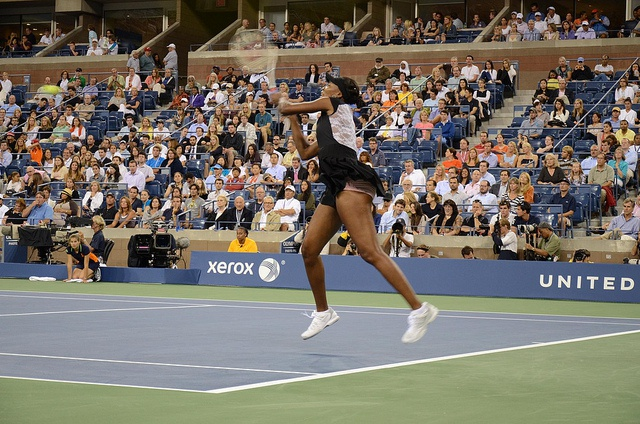Describe the objects in this image and their specific colors. I can see people in olive, black, gray, and darkgray tones, people in olive, black, maroon, gray, and darkgray tones, chair in olive, black, gray, navy, and darkgray tones, tennis racket in olive, tan, and gray tones, and people in olive, black, tan, and gray tones in this image. 